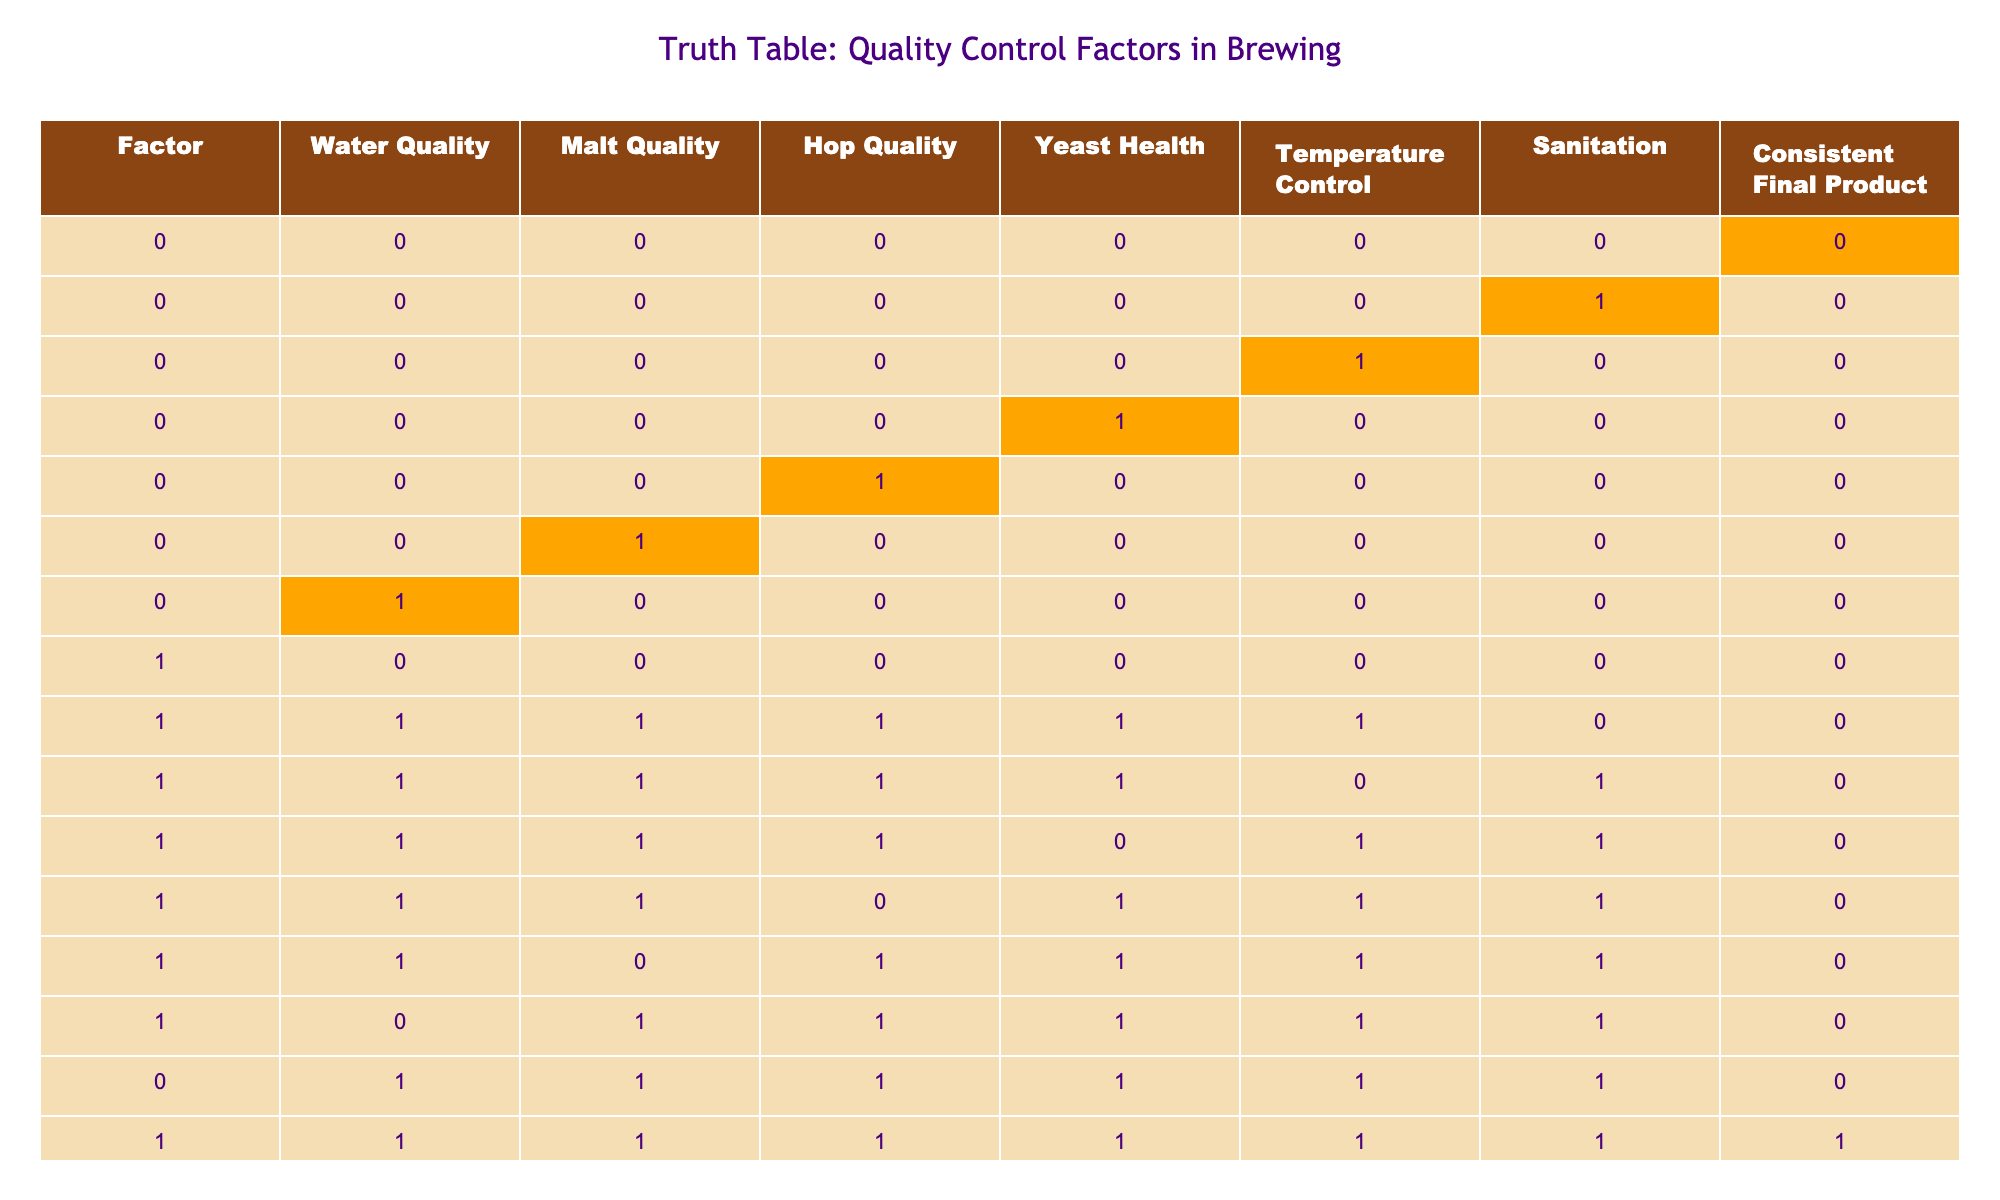What is the impact of having all control factors being zero on the final product consistency? The row with all control factors being zero indicates that there is no quality in any aspect of brewing. This leads to a final product consistency rated as zero, meaning it is completely inconsistent and likely unsaleable.
Answer: Zero How many combinations of quality factors lead to a consistent final product? By reviewing the table, there are 5 instances (rows) where the final product is consistent, indicated by a 1. This shows how many combinations of the quality control factors resulted in a consistent final product.
Answer: Five What happens to the product consistency when malt quality is high but yeast health is low? In the table, looking for high malt quality (1) and low yeast health (0), we find two instances. Both result in an inconsistent product (0), indicating that high malt quality alone is insufficient without healthy yeast to ensure product consistency.
Answer: Inconsistent If all factors are high, how does it affect final product consistency? The row with all factors marked as high (1) shows the outcome of a final product consistency marked as 1, indicating that when every quality control factor is well managed, the product is consistently high quality.
Answer: Consistent Is sanitation crucial for achieving a consistent final product? By analyzing the rows where sanitation is either present (1) or absent (0) and how they correlate with product consistency, there is a notable impact. Specifically, when sanitation is absent, consistent products are less frequent or entirely impossible. Therefore, sanitation plays an important role in achieving product consistency.
Answer: Yes What would happen if we only had high quality yeast and low temperature control? We can find instances in the table with high yeast health (1) and low temperature control (0). There are two rows meeting this criteria, with both of them resulting in inconsistent products (0), indicating that high yeast health alone cannot compensate for poor temperature control.
Answer: Inconsistent What is the average number of quality factors that are high for those rows with consistent final products? Rows that lead to consistent final products show high quality factors across different aspects. Adding the count of high factors in those rows and averaging gives us an insight into the minimum quality requirements. Calculating gives a total of 14 high factors across 5 rows, resulting in an average of 2.8 factors per row.
Answer: 2.8 In which scenario does low water quality lead to product consistency? After analyzing the rows where water quality is marked as low (0), the final product is marked consistent only when other factors are sufficiently high. Cross-referencing shows a rare scenario where low water quality combined with high malt, hop, yeast, temperature, and sanitation leads to consistency, highlighting the interactions between factors in brewing.
Answer: Only via multiple high factors 